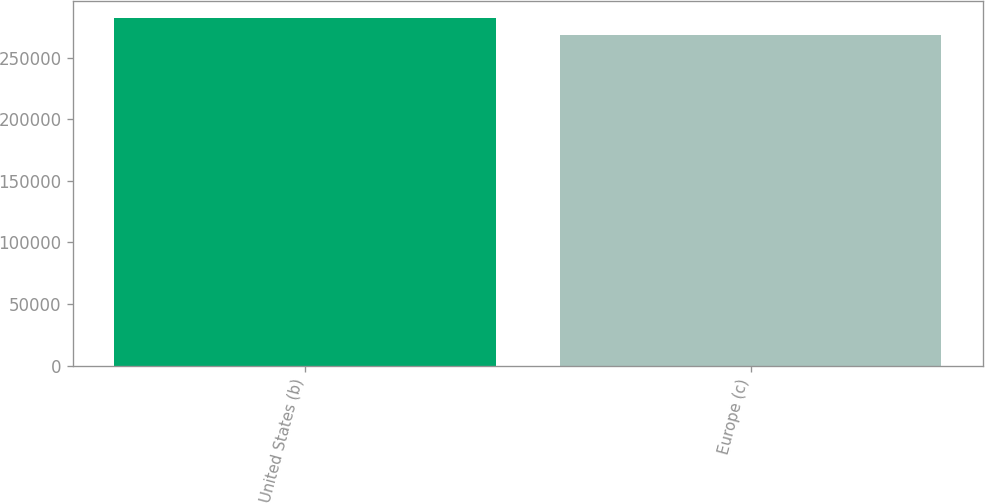Convert chart to OTSL. <chart><loc_0><loc_0><loc_500><loc_500><bar_chart><fcel>United States (b)<fcel>Europe (c)<nl><fcel>281974<fcel>268299<nl></chart> 